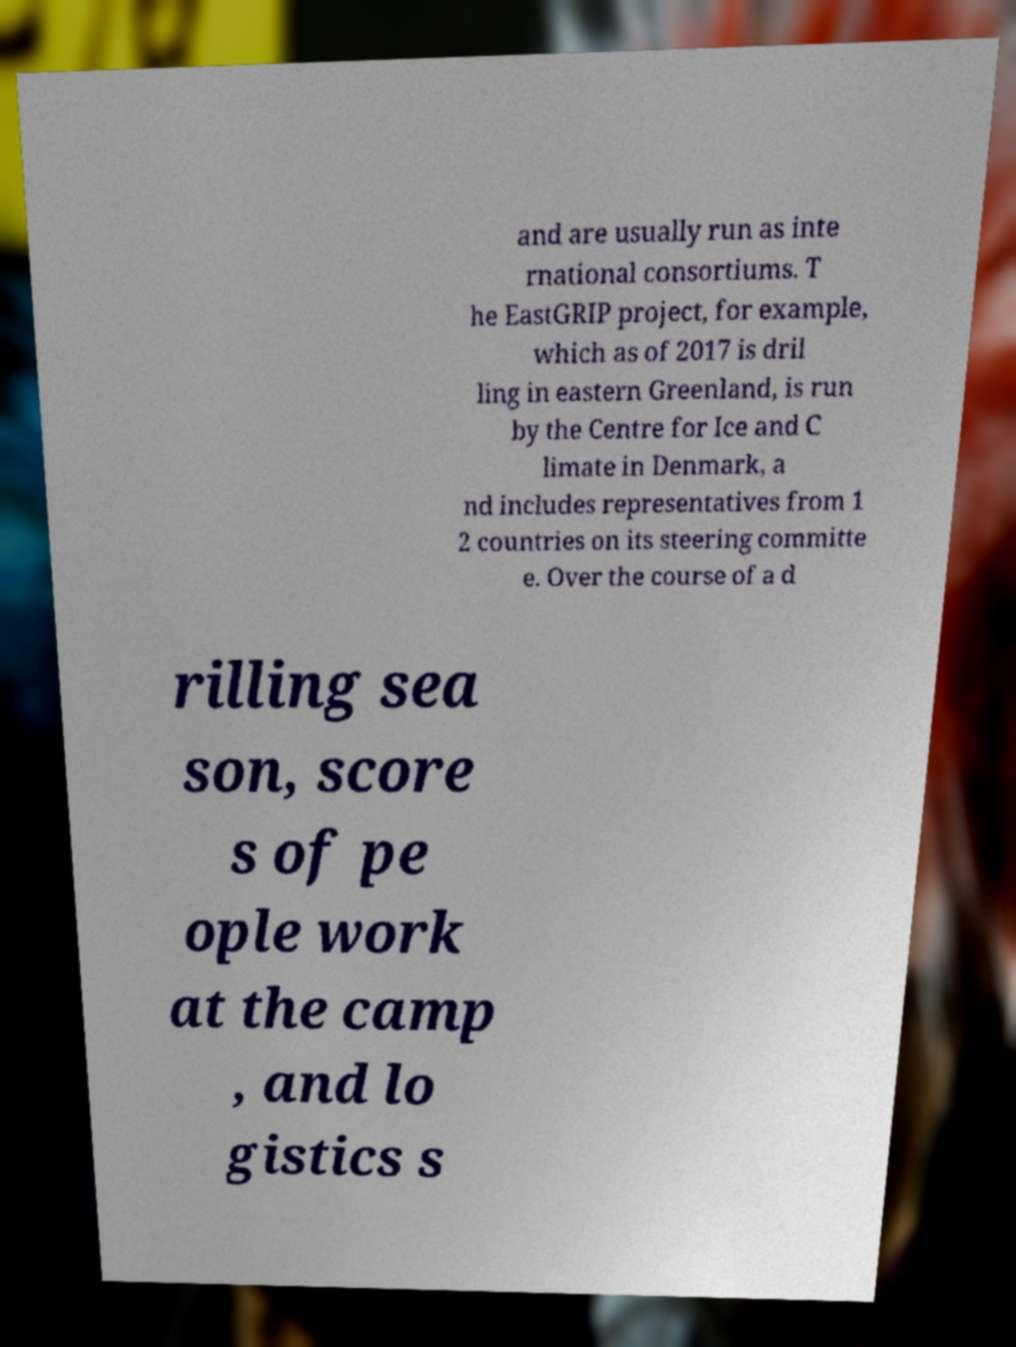Can you read and provide the text displayed in the image?This photo seems to have some interesting text. Can you extract and type it out for me? and are usually run as inte rnational consortiums. T he EastGRIP project, for example, which as of 2017 is dril ling in eastern Greenland, is run by the Centre for Ice and C limate in Denmark, a nd includes representatives from 1 2 countries on its steering committe e. Over the course of a d rilling sea son, score s of pe ople work at the camp , and lo gistics s 